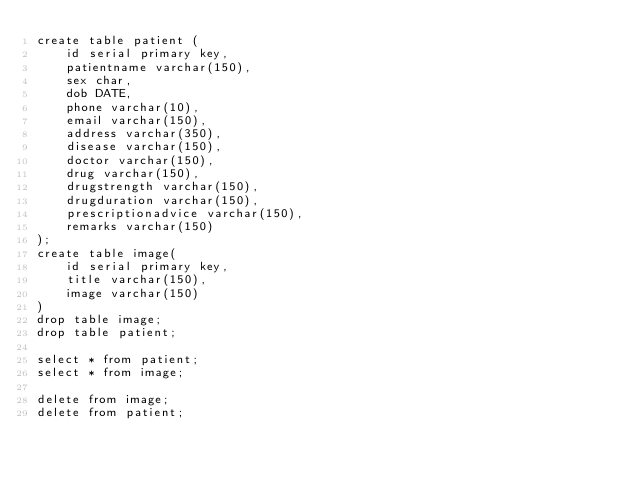<code> <loc_0><loc_0><loc_500><loc_500><_SQL_>create table patient (
	id serial primary key,
	patientname varchar(150), 
	sex char,
	dob DATE,
	phone varchar(10),
	email varchar(150),
	address varchar(350),
	disease varchar(150),
	doctor varchar(150),
	drug varchar(150),
	drugstrength varchar(150),
	drugduration varchar(150),
	prescriptionadvice varchar(150),
	remarks varchar(150)
);
create table image(
	id serial primary key,
	title varchar(150),
	image varchar(150)
)
drop table image;
drop table patient;

select * from patient;
select * from image;

delete from image;
delete from patient;
</code> 